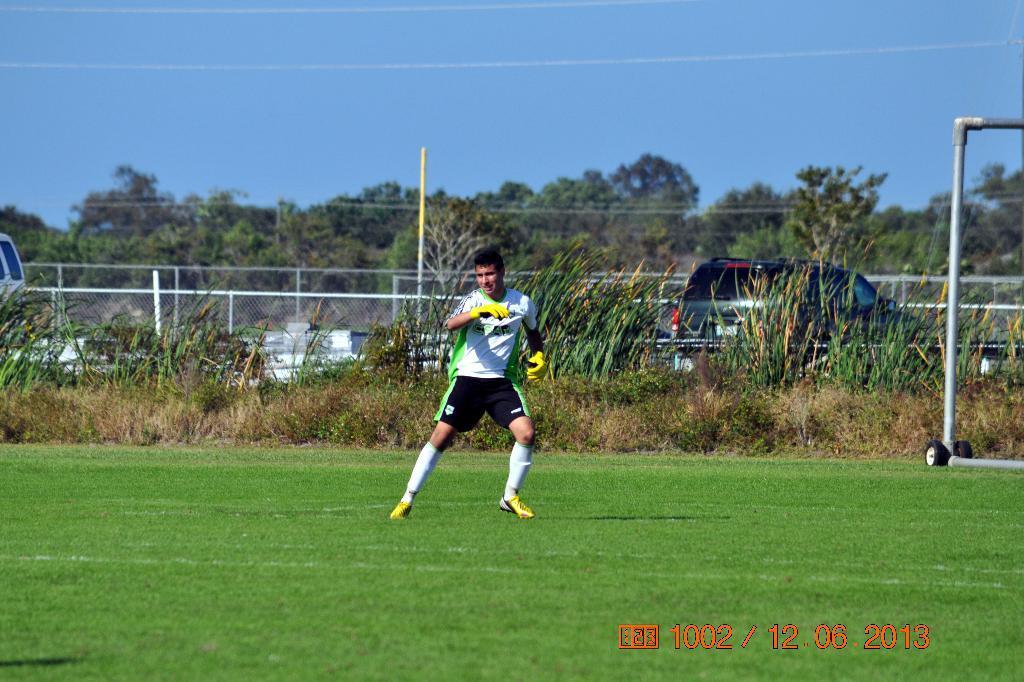Can you describe this image briefly? At the center of the image there is a person standing on the surface of the grass. On the right side there is an iron structure, behind the person there is a grass and two vehicles moving on the road. In the background there is a railing, trees and a sky. 